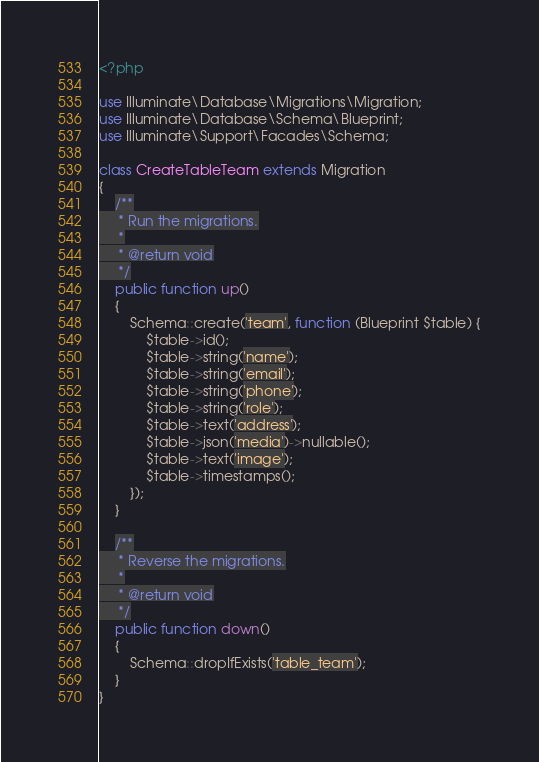Convert code to text. <code><loc_0><loc_0><loc_500><loc_500><_PHP_><?php

use Illuminate\Database\Migrations\Migration;
use Illuminate\Database\Schema\Blueprint;
use Illuminate\Support\Facades\Schema;

class CreateTableTeam extends Migration
{
    /**
     * Run the migrations.
     *
     * @return void
     */
    public function up()
    {
        Schema::create('team', function (Blueprint $table) {
            $table->id();
            $table->string('name');
            $table->string('email');
            $table->string('phone');
            $table->string('role');
            $table->text('address');
            $table->json('media')->nullable();
            $table->text('image');
            $table->timestamps();
        });
    }

    /**
     * Reverse the migrations.
     *
     * @return void
     */
    public function down()
    {
        Schema::dropIfExists('table_team');
    }
}
</code> 